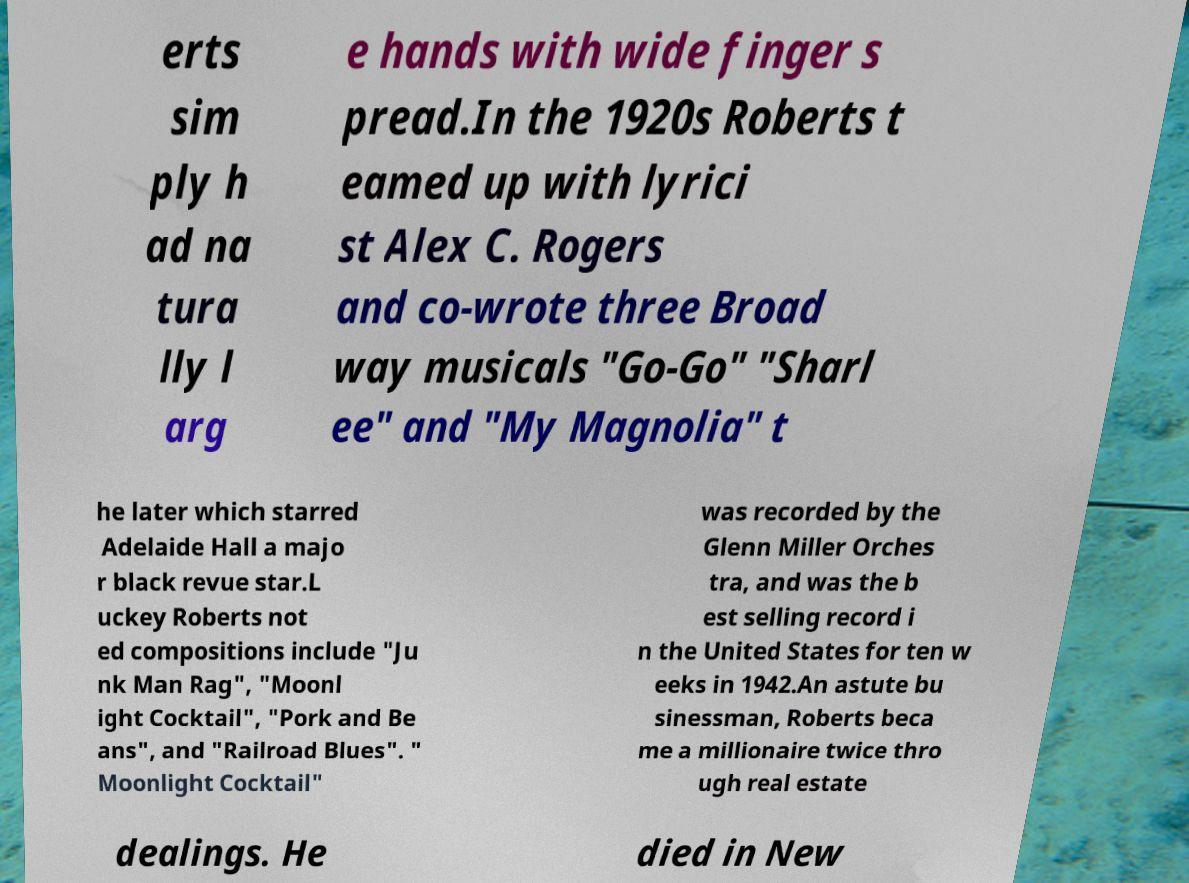Please read and relay the text visible in this image. What does it say? erts sim ply h ad na tura lly l arg e hands with wide finger s pread.In the 1920s Roberts t eamed up with lyrici st Alex C. Rogers and co-wrote three Broad way musicals "Go-Go" "Sharl ee" and "My Magnolia" t he later which starred Adelaide Hall a majo r black revue star.L uckey Roberts not ed compositions include "Ju nk Man Rag", "Moonl ight Cocktail", "Pork and Be ans", and "Railroad Blues". " Moonlight Cocktail" was recorded by the Glenn Miller Orches tra, and was the b est selling record i n the United States for ten w eeks in 1942.An astute bu sinessman, Roberts beca me a millionaire twice thro ugh real estate dealings. He died in New 